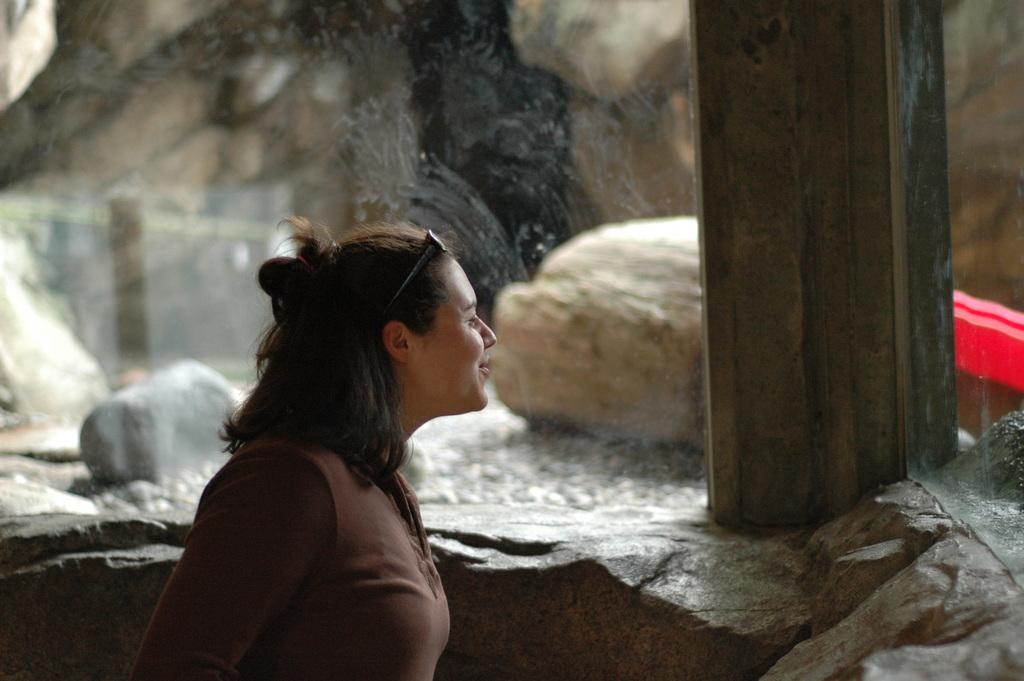What is the main subject of the image? There is a lady standing in the image. Can you describe the background of the image? There are rocks in the background of the image. What type of vein is visible on the lady's hand in the image? There is no visible vein on the lady's hand in the image. What is the lady using to rake the rocks in the background? There is no rake present in the image, and the lady is not performing any action with the rocks. 